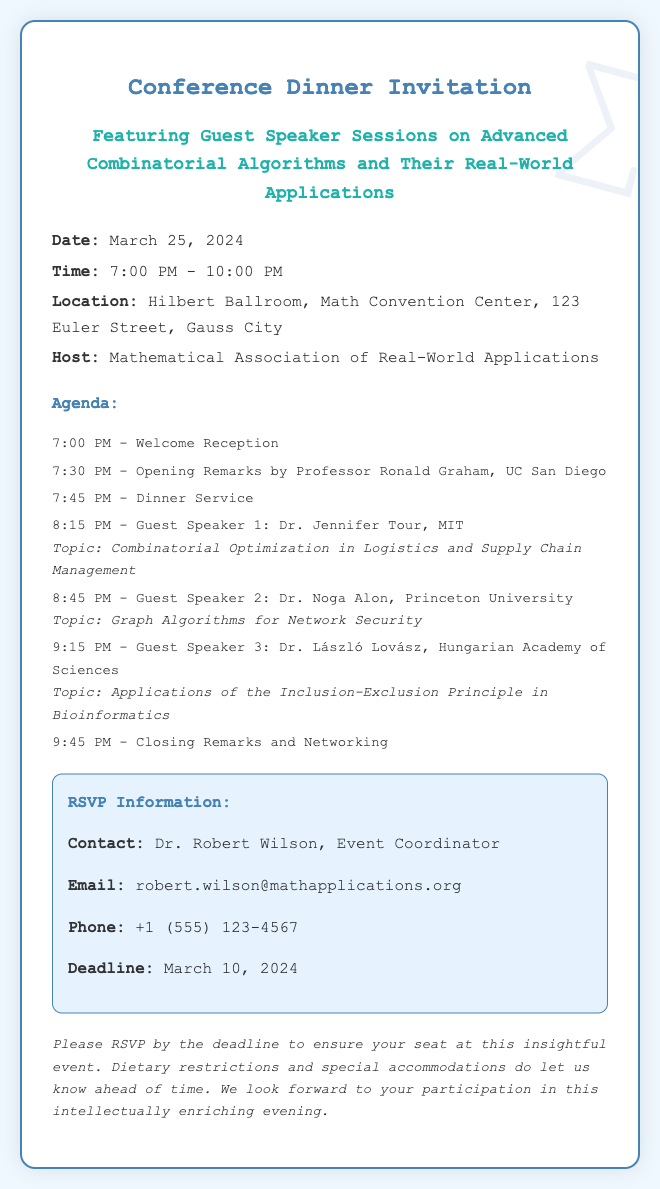What is the date of the conference dinner? The date is explicitly mentioned in the document as March 25, 2024.
Answer: March 25, 2024 What time does the dinner service start? The document specifies the dinner service time as 7:45 PM.
Answer: 7:45 PM Who is the host of the event? The host is clearly identified in the document as the Mathematical Association of Real-World Applications.
Answer: Mathematical Association of Real-World Applications How many guest speakers are there? By counting the listed guest speakers in the agenda, there are three speakers.
Answer: 3 What is the topic of Dr. László Lovász's talk? The topic is listed in the agenda as "Applications of the Inclusion-Exclusion Principle in Bioinformatics."
Answer: Applications of the Inclusion-Exclusion Principle in Bioinformatics Who should attendees contact for RSVP? The document states that attendees should contact Dr. Robert Wilson for RSVP information.
Answer: Dr. Robert Wilson What is the RSVP deadline? The RSVP deadline is mentioned in the document as March 10, 2024.
Answer: March 10, 2024 What location is mentioned for the event? The location is specified as Hilbert Ballroom, Math Convention Center, 123 Euler Street, Gauss City.
Answer: Hilbert Ballroom, Math Convention Center, 123 Euler Street, Gauss City What type of event is this document for? The document is explicitly described as an invitation for a conference dinner.
Answer: Conference dinner 